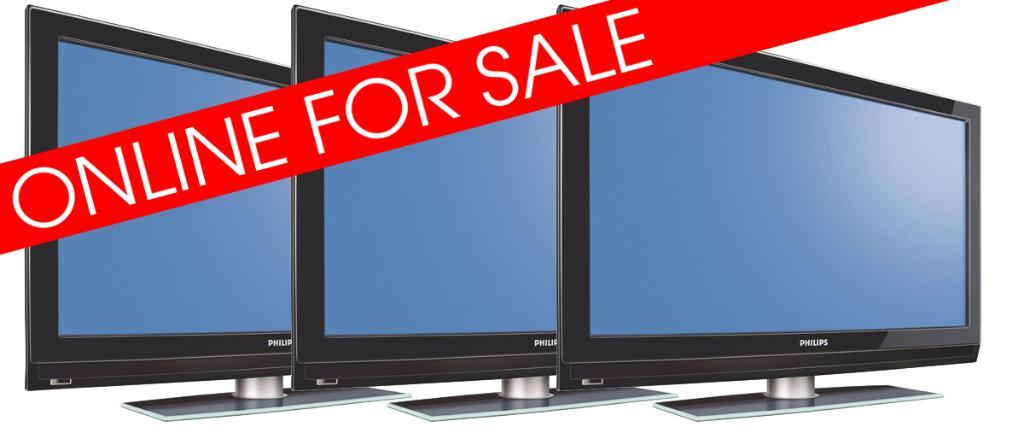<image>
Present a compact description of the photo's key features. Three flat screen TVs are advertised as being on sale. 